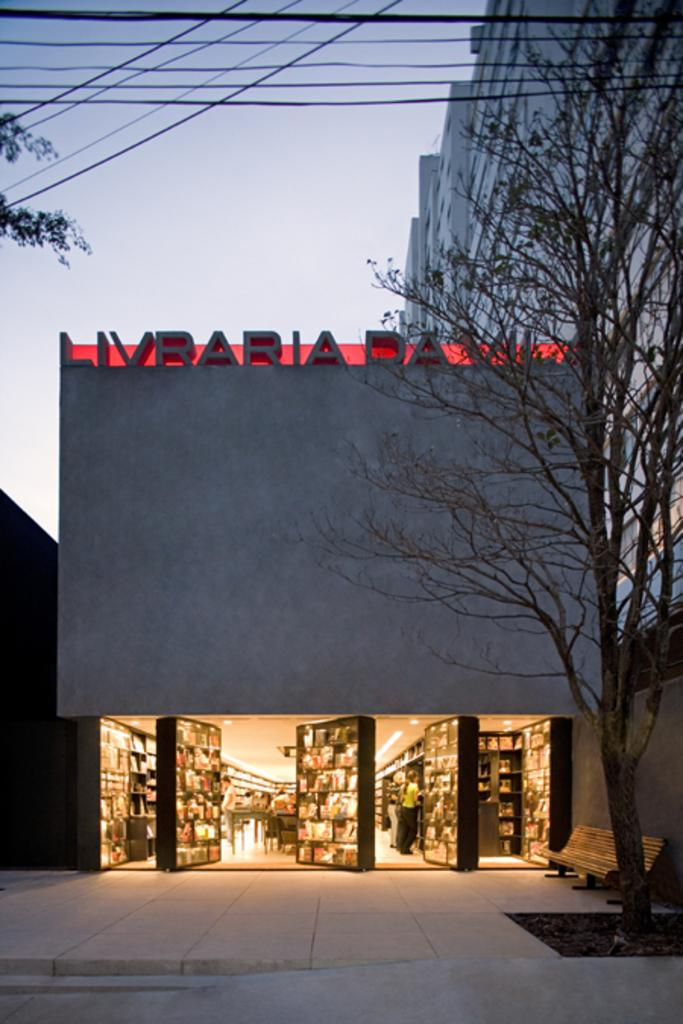What type of natural elements can be seen in the image? There are trees in the image. What type of establishment is present in the image? There is a store in the image. What is visible at the top of the image? There are wires visible at the top of the image. What type of structures are present in the image? There are buildings in the image. What is the condition of the sky in the image? The sky is clear and visible in the image. What type of iron is being used for the voyage in the image? There is no iron or voyage present in the image. What rule is being enforced by the trees in the image? There is no rule being enforced by the trees in the image; they are simply natural elements in the scene. 